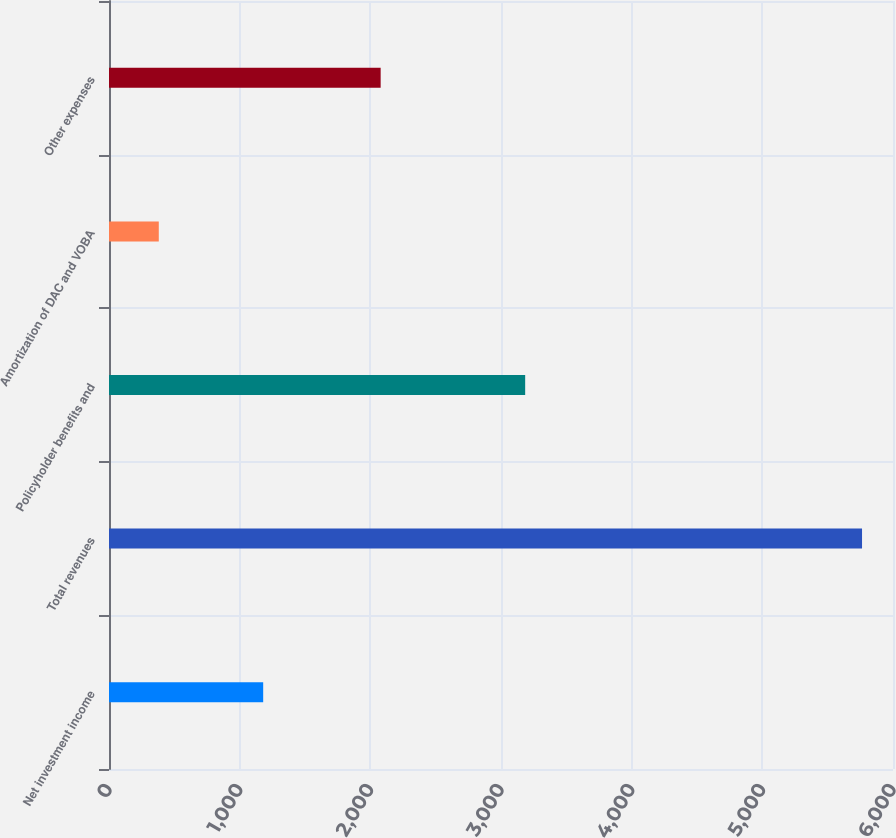Convert chart. <chart><loc_0><loc_0><loc_500><loc_500><bar_chart><fcel>Net investment income<fcel>Total revenues<fcel>Policyholder benefits and<fcel>Amortization of DAC and VOBA<fcel>Other expenses<nl><fcel>1180<fcel>5763<fcel>3185<fcel>381<fcel>2079<nl></chart> 